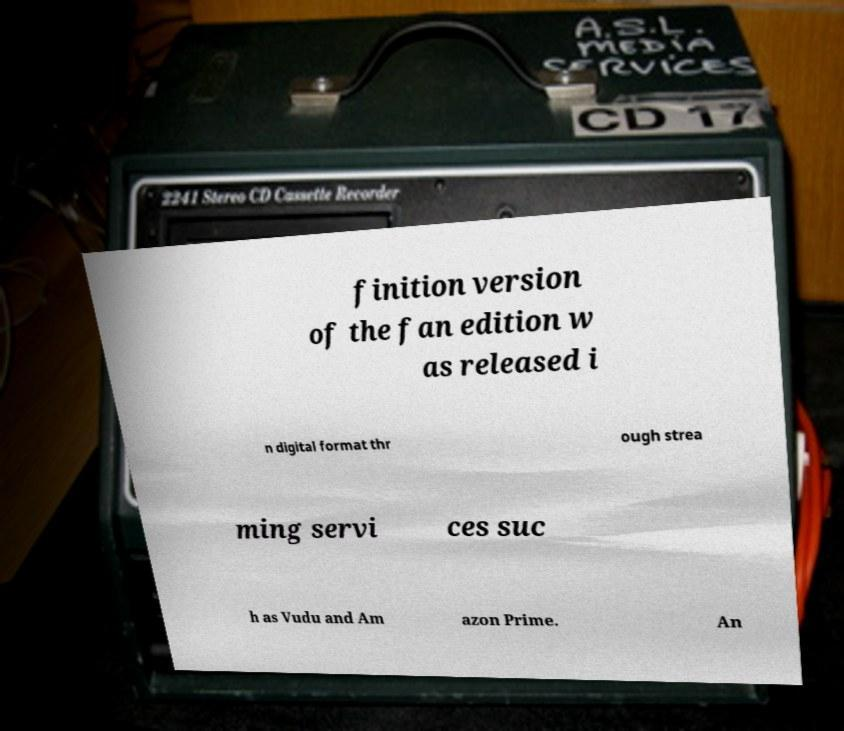Could you assist in decoding the text presented in this image and type it out clearly? finition version of the fan edition w as released i n digital format thr ough strea ming servi ces suc h as Vudu and Am azon Prime. An 